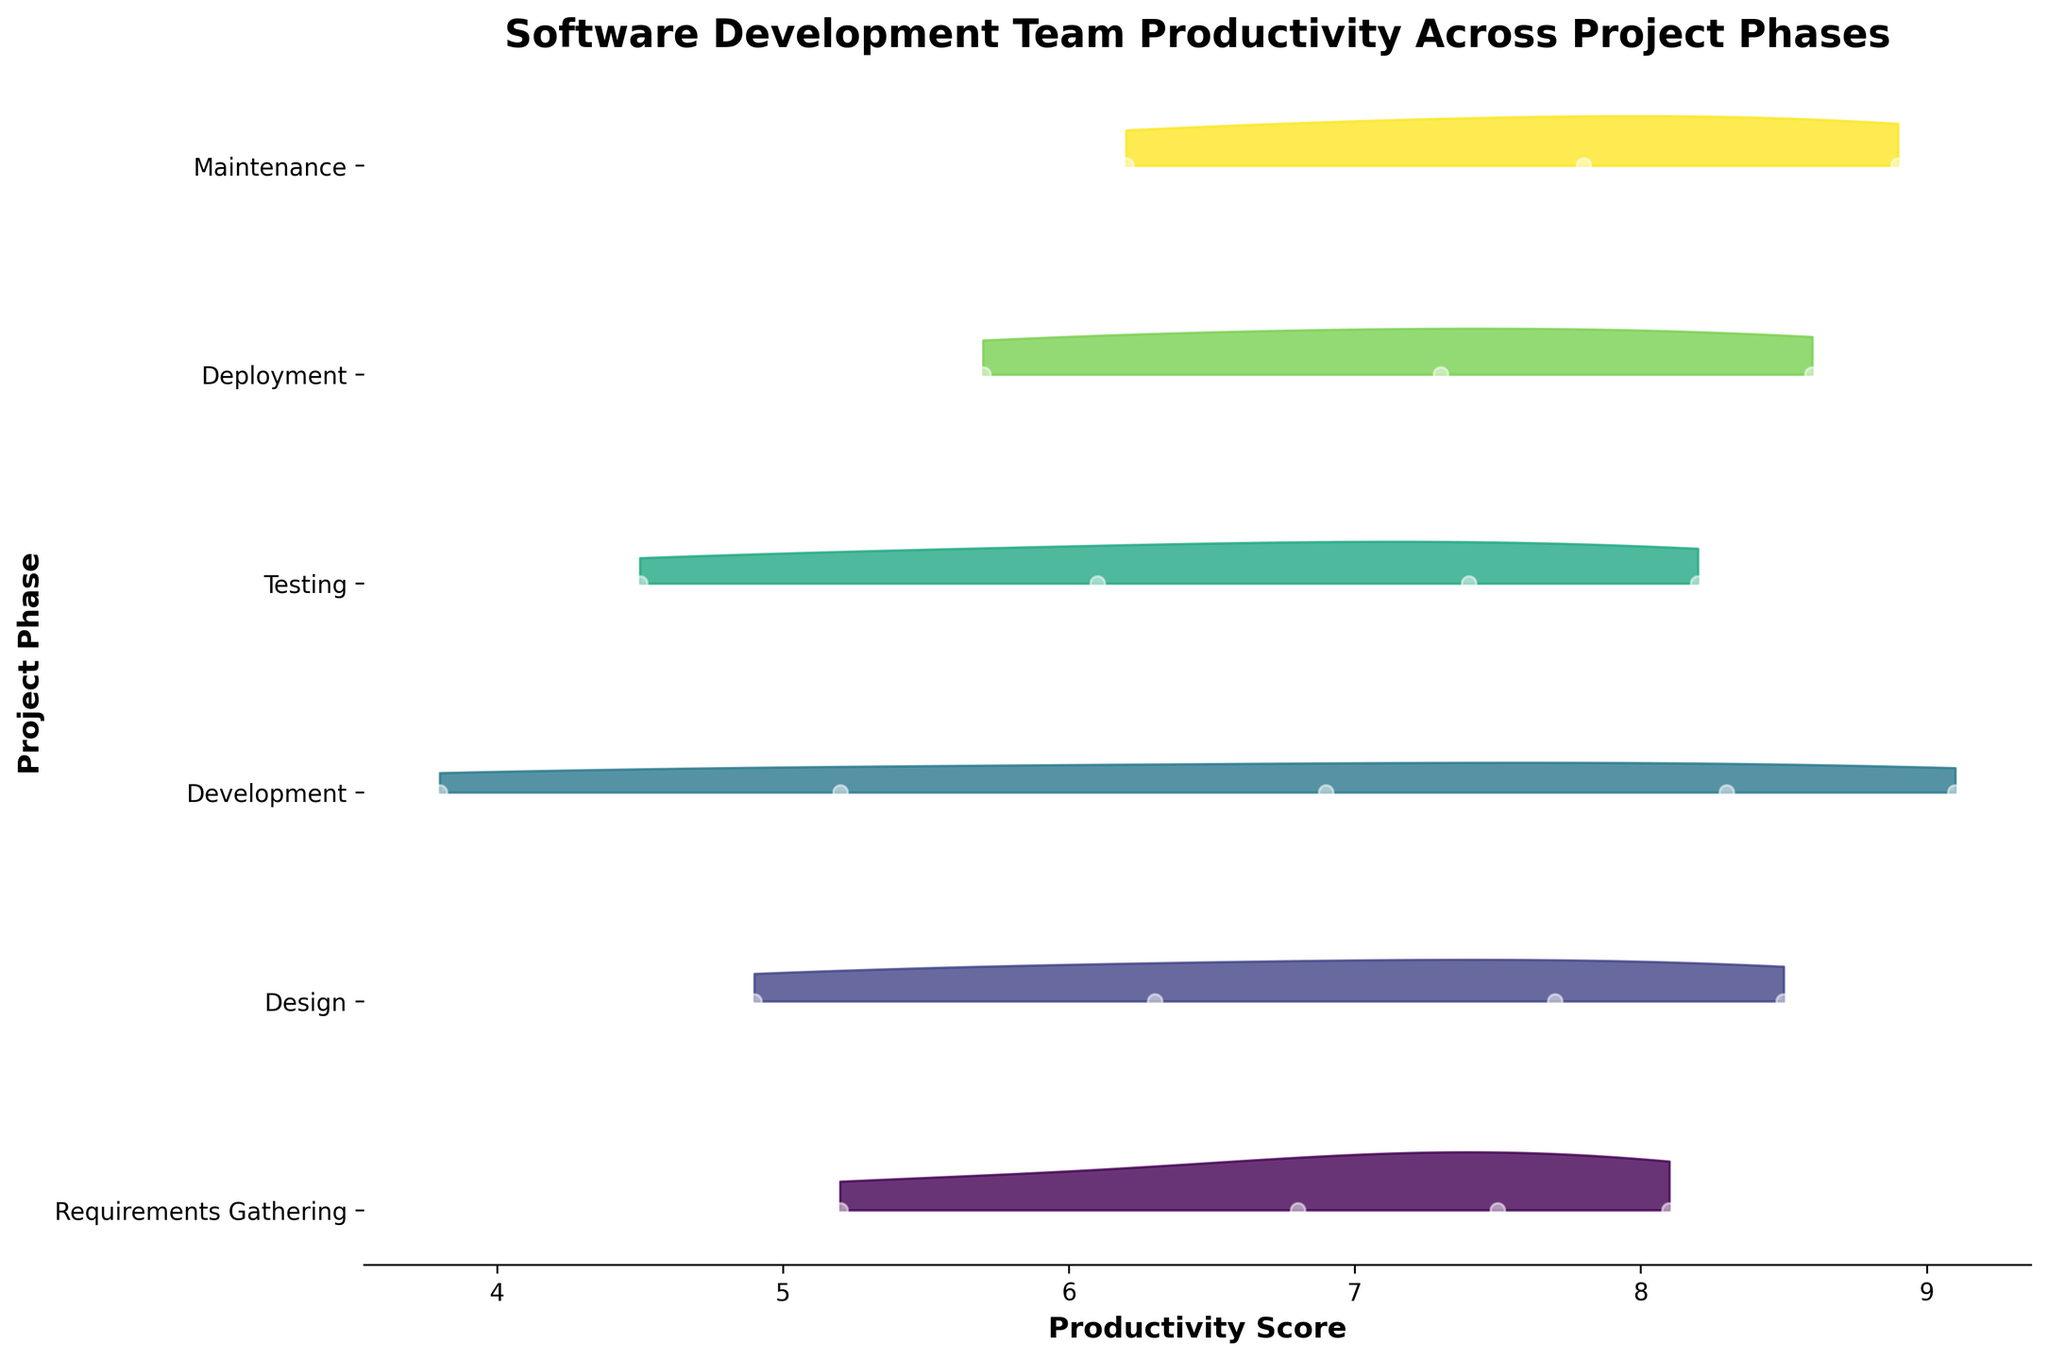What is the title of the figure? The title is usually located at the top of the figure, positioned centrally. From the details, we know it's titled "Software Development Team Productivity Across Project Phases".
Answer: "Software Development Team Productivity Across Project Phases" How many project phases are represented in the figure? By counting the unique labels on the y-axis, we can see there are the phases: Requirements Gathering, Design, Development, Testing, Deployment, and Maintenance. This totals to six phases.
Answer: Six Which project phase shows the highest overall productivity score? By examining the peaks of the ridgeline plots, Development phase has the highest point around a productivity score of 9.1, which indicates it has the highest productivity score overall.
Answer: Development In which phase does productivity significantly increase from one week to the next? By looking at the points and the gradient of the ridgelines for steep increases, Development phase shows a substantial increase from week 7 to week 8, and Testing phase shows an increase from week 8 to week 9.
Answer: Development (week 7 to week 8) and Testing (week 8 to week 9) How does the productivity score progression in 'Design' compare to that in 'Development'? By comparing the general trend of productivity scores in Design and Development phases: Design shows a steady increase from lower scores to higher scores, while Development starts from lower scores and rises more steeply towards the later weeks.
Answer: Design has a steady increase, Development has a steep increase towards the end Which project phase has the lowest productivity score and what is that score? By looking at the minimum points on the ridgeline plots, the Development phase has the lowest score, observed around 3.8.
Answer: Development, 3.8 Is there any phase where productivity scores fluctuate significantly? Testing phase has a range represented by multiple discrete points, indicating fluctuations from 4.5 to 8.2. Similarly, Development has ranges from 3.8 to 9.1. These phases show marked fluctuation.
Answer: Testing and Development Between which two phases is the smallest difference in the highest productivity scores observed? By comparing the peak productivity scores of each phase, the smallest difference in peak scores is between Testing (8.2) and Deployment (8.6), a difference of 0.4.
Answer: Testing and Deployment What is the average highest productivity score observed across all phases? First, identify the peak score for each phase: Requirements Gathering (8.1), Design (8.5), Development (9.1), Testing (8.2), Deployment (8.6), Maintenance (8.9). Average these scores: (8.1 + 8.5 + 9.1 + 8.2 + 8.6 + 8.9) / 6 = 8.57.
Answer: 8.57 Which phase shows a consistent score without much variation? Look for a phase where the density plot is narrow and mostly concentrated around a single score value, indicating less variation. Requirements Gathering phase shows relatively less variation, ranging mostly between 5.2 and 8.1.
Answer: Requirements Gathering 